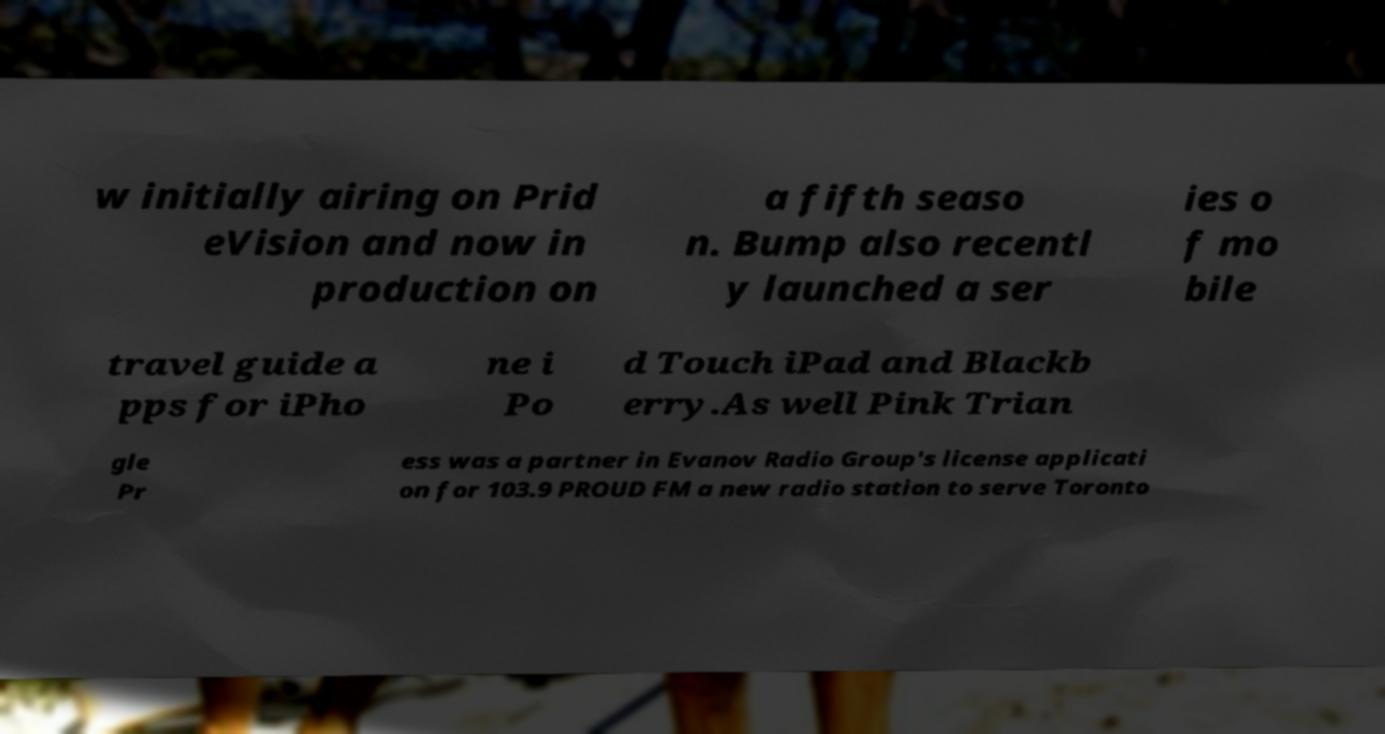What messages or text are displayed in this image? I need them in a readable, typed format. w initially airing on Prid eVision and now in production on a fifth seaso n. Bump also recentl y launched a ser ies o f mo bile travel guide a pps for iPho ne i Po d Touch iPad and Blackb erry.As well Pink Trian gle Pr ess was a partner in Evanov Radio Group's license applicati on for 103.9 PROUD FM a new radio station to serve Toronto 